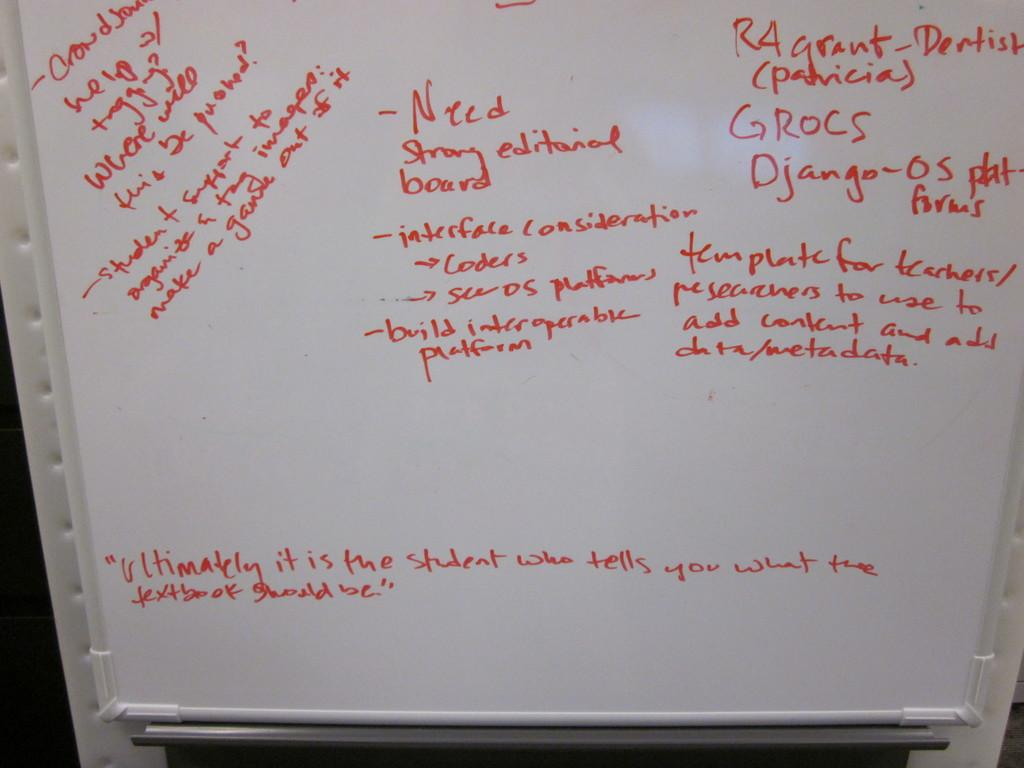<image>
Provide a brief description of the given image. A whiteboard has red handwriting on it and says Need strong editorial board. 